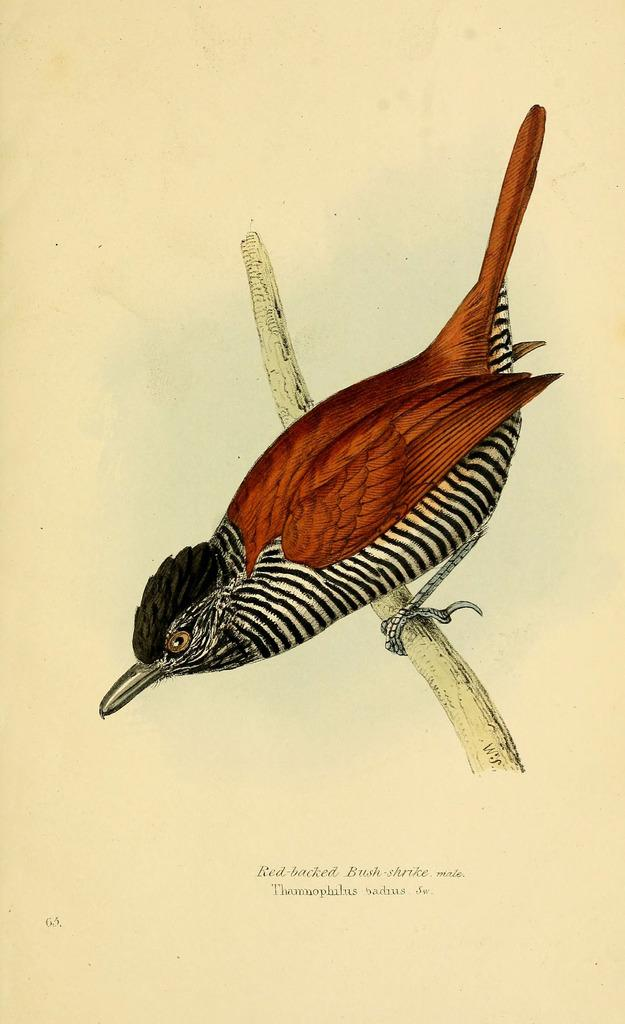What is the main subject of the image? The main subject of the image is a bird. Where is the bird located in the image? The bird is on the branch of a tree. Is there any text visible in the image? Yes, there is some text visible in the image. Can you tell me how many hens are visible in the image? There are no hens present in the image; it features a bird on a tree branch. What type of hair can be seen on the bird in the image? Birds do not have hair, so there is no hair visible on the bird in the image. 